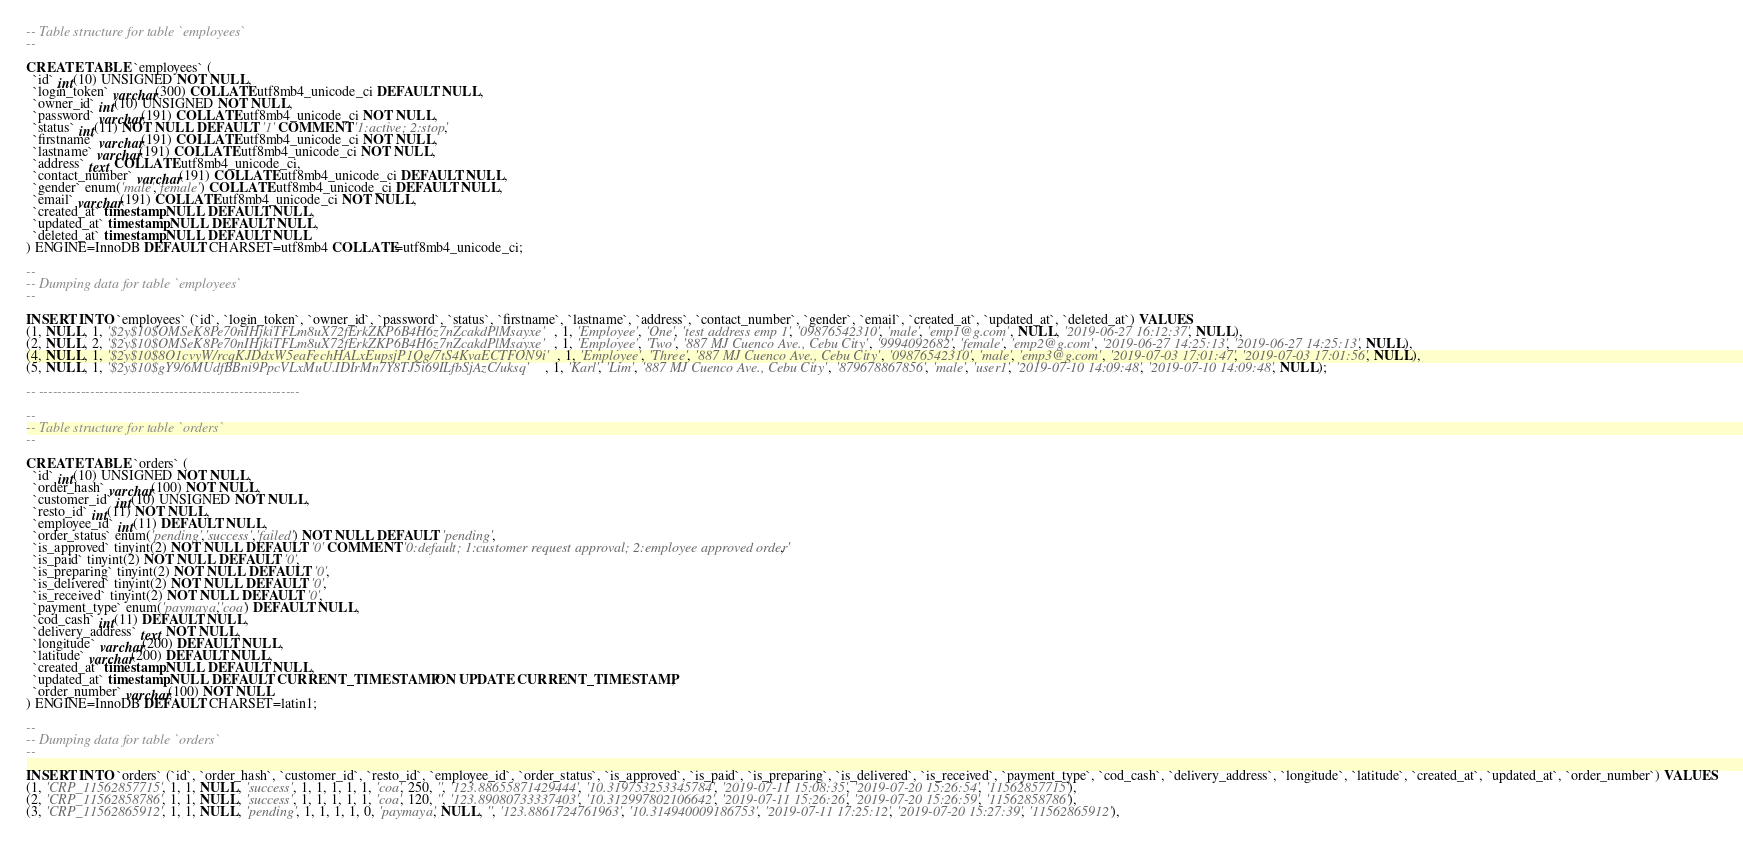<code> <loc_0><loc_0><loc_500><loc_500><_SQL_>-- Table structure for table `employees`
--

CREATE TABLE `employees` (
  `id` int(10) UNSIGNED NOT NULL,
  `login_token` varchar(300) COLLATE utf8mb4_unicode_ci DEFAULT NULL,
  `owner_id` int(10) UNSIGNED NOT NULL,
  `password` varchar(191) COLLATE utf8mb4_unicode_ci NOT NULL,
  `status` int(11) NOT NULL DEFAULT '1' COMMENT '1:active; 2:stop',
  `firstname` varchar(191) COLLATE utf8mb4_unicode_ci NOT NULL,
  `lastname` varchar(191) COLLATE utf8mb4_unicode_ci NOT NULL,
  `address` text COLLATE utf8mb4_unicode_ci,
  `contact_number` varchar(191) COLLATE utf8mb4_unicode_ci DEFAULT NULL,
  `gender` enum('male','female') COLLATE utf8mb4_unicode_ci DEFAULT NULL,
  `email` varchar(191) COLLATE utf8mb4_unicode_ci NOT NULL,
  `created_at` timestamp NULL DEFAULT NULL,
  `updated_at` timestamp NULL DEFAULT NULL,
  `deleted_at` timestamp NULL DEFAULT NULL
) ENGINE=InnoDB DEFAULT CHARSET=utf8mb4 COLLATE=utf8mb4_unicode_ci;

--
-- Dumping data for table `employees`
--

INSERT INTO `employees` (`id`, `login_token`, `owner_id`, `password`, `status`, `firstname`, `lastname`, `address`, `contact_number`, `gender`, `email`, `created_at`, `updated_at`, `deleted_at`) VALUES
(1, NULL, 1, '$2y$10$OMSeK8Pe70nIHjkiTFLm8uX72fErkZKP6B4H6z7nZcakdPlMsayxe', 1, 'Employee', 'One', 'test address emp 1', '09876542310', 'male', 'emp1@g.com', NULL, '2019-06-27 16:12:37', NULL),
(2, NULL, 2, '$2y$10$OMSeK8Pe70nIHjkiTFLm8uX72fErkZKP6B4H6z7nZcakdPlMsayxe', 1, 'Employee', 'Two', '887 MJ Cuenco Ave., Cebu City', '9994092682', 'female', 'emp2@g.com', '2019-06-27 14:25:13', '2019-06-27 14:25:13', NULL),
(4, NULL, 1, '$2y$10$8O1cvyW/rcqKJDdxW5eaFechHALxEupsjP1Qg/7tS4KvaECTFON9i', 1, 'Employee', 'Three', '887 MJ Cuenco Ave., Cebu City', '09876542310', 'male', 'emp3@g.com', '2019-07-03 17:01:47', '2019-07-03 17:01:56', NULL),
(5, NULL, 1, '$2y$10$gY9/6MUdfBBni9PpcVLxMuU.IDIrMn7Y8TJ5i69ILfbSjAzC/uksq', 1, 'Karl', 'Lim', '887 MJ Cuenco Ave., Cebu City', '879678867856', 'male', 'user1', '2019-07-10 14:09:48', '2019-07-10 14:09:48', NULL);

-- --------------------------------------------------------

--
-- Table structure for table `orders`
--

CREATE TABLE `orders` (
  `id` int(10) UNSIGNED NOT NULL,
  `order_hash` varchar(100) NOT NULL,
  `customer_id` int(10) UNSIGNED NOT NULL,
  `resto_id` int(11) NOT NULL,
  `employee_id` int(11) DEFAULT NULL,
  `order_status` enum('pending','success','failed') NOT NULL DEFAULT 'pending',
  `is_approved` tinyint(2) NOT NULL DEFAULT '0' COMMENT '0:default; 1:customer request approval; 2:employee approved order',
  `is_paid` tinyint(2) NOT NULL DEFAULT '0',
  `is_preparing` tinyint(2) NOT NULL DEFAULT '0',
  `is_delivered` tinyint(2) NOT NULL DEFAULT '0',
  `is_received` tinyint(2) NOT NULL DEFAULT '0',
  `payment_type` enum('paymaya','coa') DEFAULT NULL,
  `cod_cash` int(11) DEFAULT NULL,
  `delivery_address` text NOT NULL,
  `longitude` varchar(200) DEFAULT NULL,
  `latitude` varchar(200) DEFAULT NULL,
  `created_at` timestamp NULL DEFAULT NULL,
  `updated_at` timestamp NULL DEFAULT CURRENT_TIMESTAMP ON UPDATE CURRENT_TIMESTAMP,
  `order_number` varchar(100) NOT NULL
) ENGINE=InnoDB DEFAULT CHARSET=latin1;

--
-- Dumping data for table `orders`
--

INSERT INTO `orders` (`id`, `order_hash`, `customer_id`, `resto_id`, `employee_id`, `order_status`, `is_approved`, `is_paid`, `is_preparing`, `is_delivered`, `is_received`, `payment_type`, `cod_cash`, `delivery_address`, `longitude`, `latitude`, `created_at`, `updated_at`, `order_number`) VALUES
(1, 'CRP_11562857715', 1, 1, NULL, 'success', 1, 1, 1, 1, 1, 'coa', 250, '', '123.88655871429444', '10.319753253345784', '2019-07-11 15:08:35', '2019-07-20 15:26:54', '11562857715'),
(2, 'CRP_11562858786', 1, 1, NULL, 'success', 1, 1, 1, 1, 1, 'coa', 120, '', '123.89080733337403', '10.312997802106642', '2019-07-11 15:26:26', '2019-07-20 15:26:59', '11562858786'),
(3, 'CRP_11562865912', 1, 1, NULL, 'pending', 1, 1, 1, 1, 0, 'paymaya', NULL, '', '123.8861724761963', '10.314940009186753', '2019-07-11 17:25:12', '2019-07-20 15:27:39', '11562865912'),</code> 